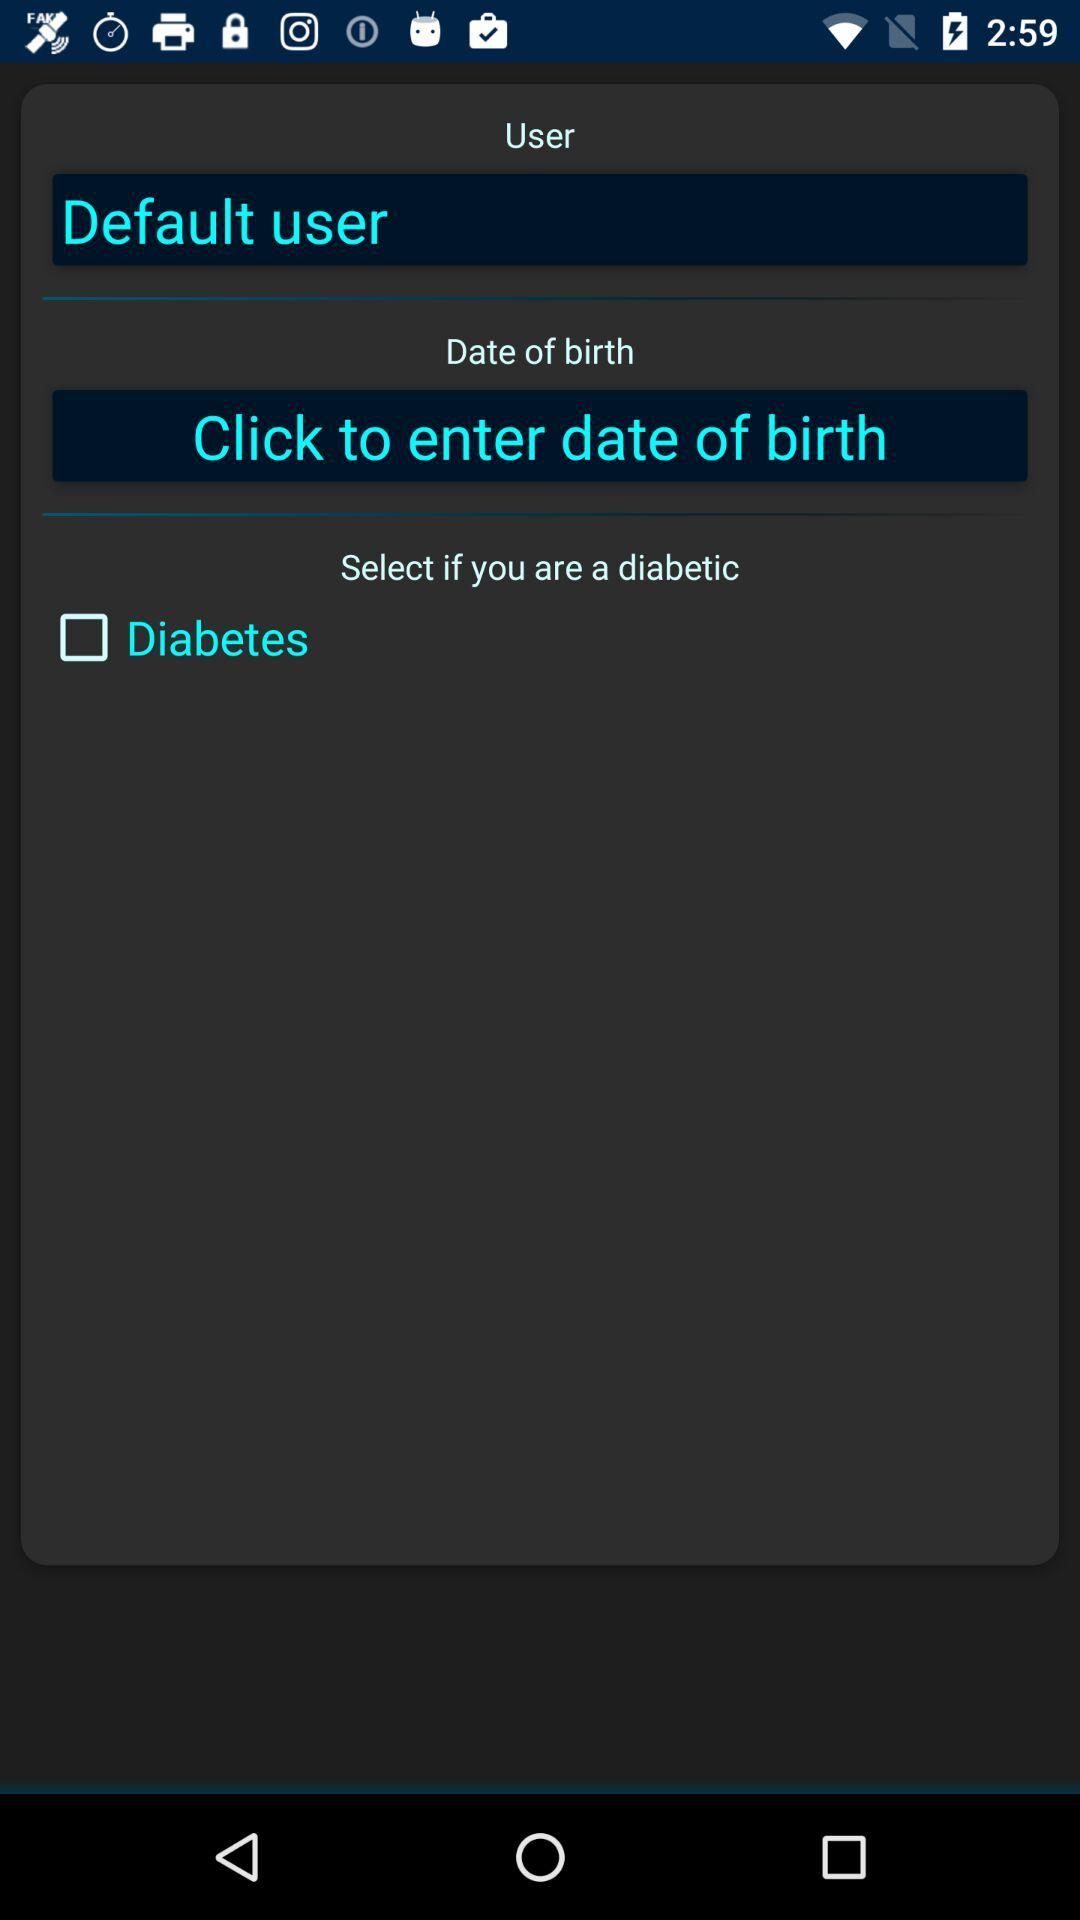What is the status of user?
When the provided information is insufficient, respond with <no answer>. <no answer> 